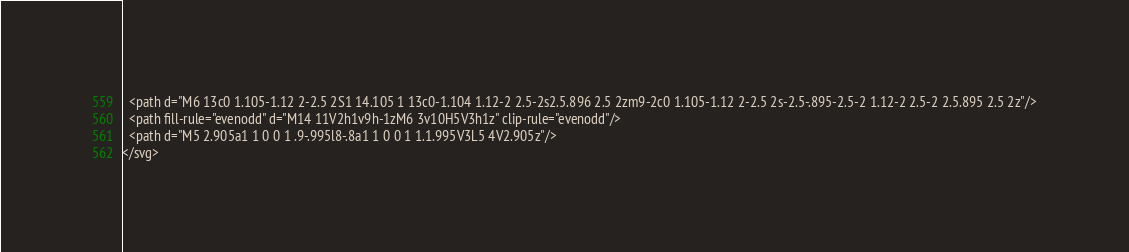<code> <loc_0><loc_0><loc_500><loc_500><_PHP_>  <path d="M6 13c0 1.105-1.12 2-2.5 2S1 14.105 1 13c0-1.104 1.12-2 2.5-2s2.5.896 2.5 2zm9-2c0 1.105-1.12 2-2.5 2s-2.5-.895-2.5-2 1.12-2 2.5-2 2.5.895 2.5 2z"/>
  <path fill-rule="evenodd" d="M14 11V2h1v9h-1zM6 3v10H5V3h1z" clip-rule="evenodd"/>
  <path d="M5 2.905a1 1 0 0 1 .9-.995l8-.8a1 1 0 0 1 1.1.995V3L5 4V2.905z"/>
</svg>
</code> 